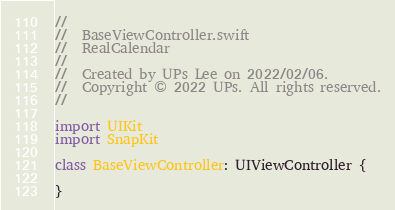Convert code to text. <code><loc_0><loc_0><loc_500><loc_500><_Swift_>//
//  BaseViewController.swift
//  RealCalendar
//
//  Created by UPs Lee on 2022/02/06.
//  Copyright © 2022 UPs. All rights reserved.
//

import UIKit
import SnapKit

class BaseViewController: UIViewController {
    
}
</code> 